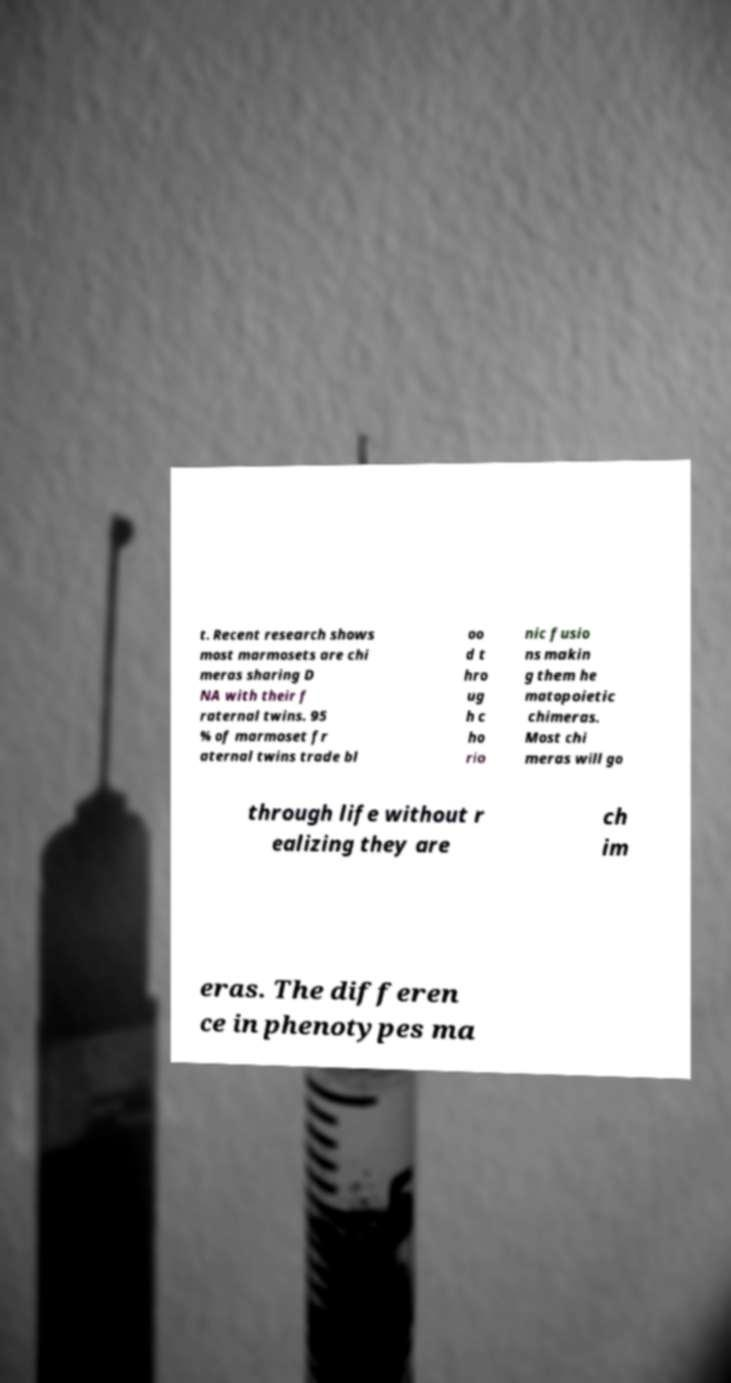What messages or text are displayed in this image? I need them in a readable, typed format. t. Recent research shows most marmosets are chi meras sharing D NA with their f raternal twins. 95 % of marmoset fr aternal twins trade bl oo d t hro ug h c ho rio nic fusio ns makin g them he matopoietic chimeras. Most chi meras will go through life without r ealizing they are ch im eras. The differen ce in phenotypes ma 